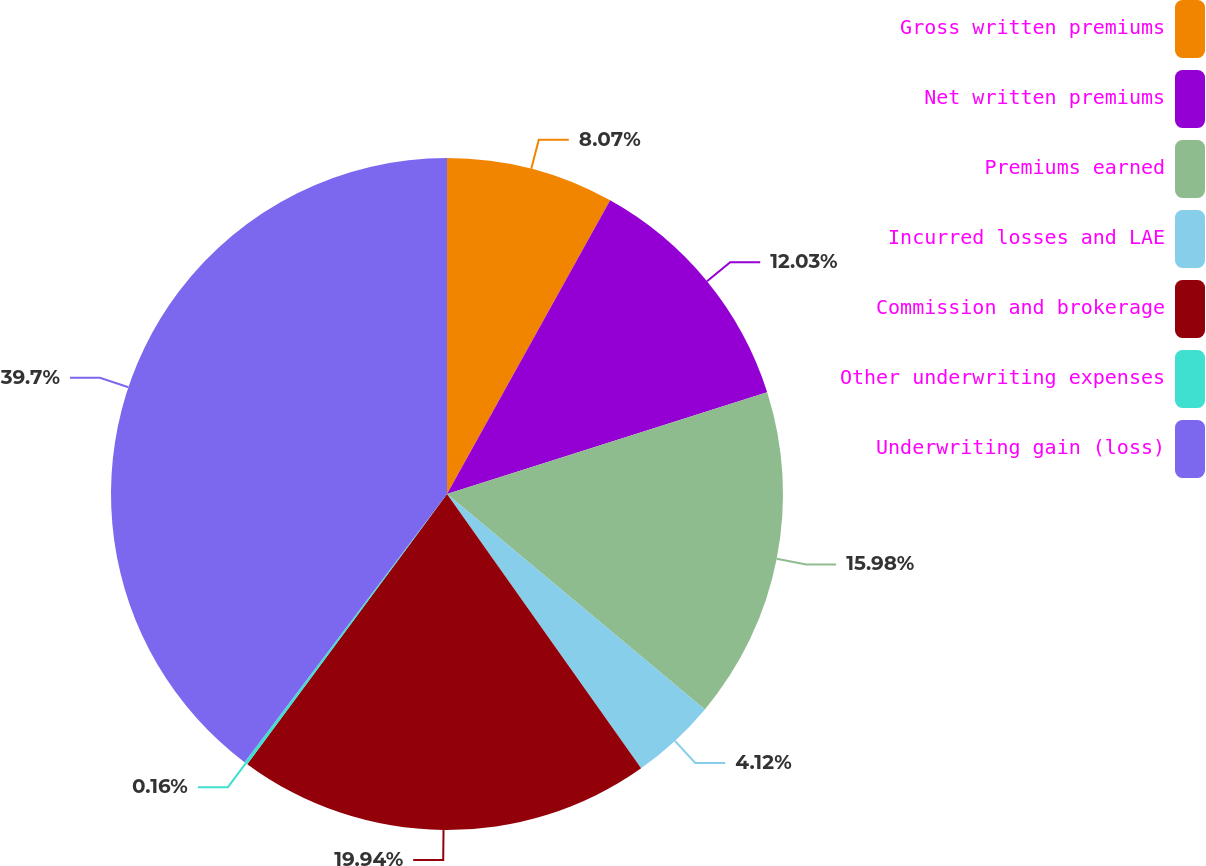<chart> <loc_0><loc_0><loc_500><loc_500><pie_chart><fcel>Gross written premiums<fcel>Net written premiums<fcel>Premiums earned<fcel>Incurred losses and LAE<fcel>Commission and brokerage<fcel>Other underwriting expenses<fcel>Underwriting gain (loss)<nl><fcel>8.07%<fcel>12.03%<fcel>15.98%<fcel>4.12%<fcel>19.94%<fcel>0.16%<fcel>39.71%<nl></chart> 